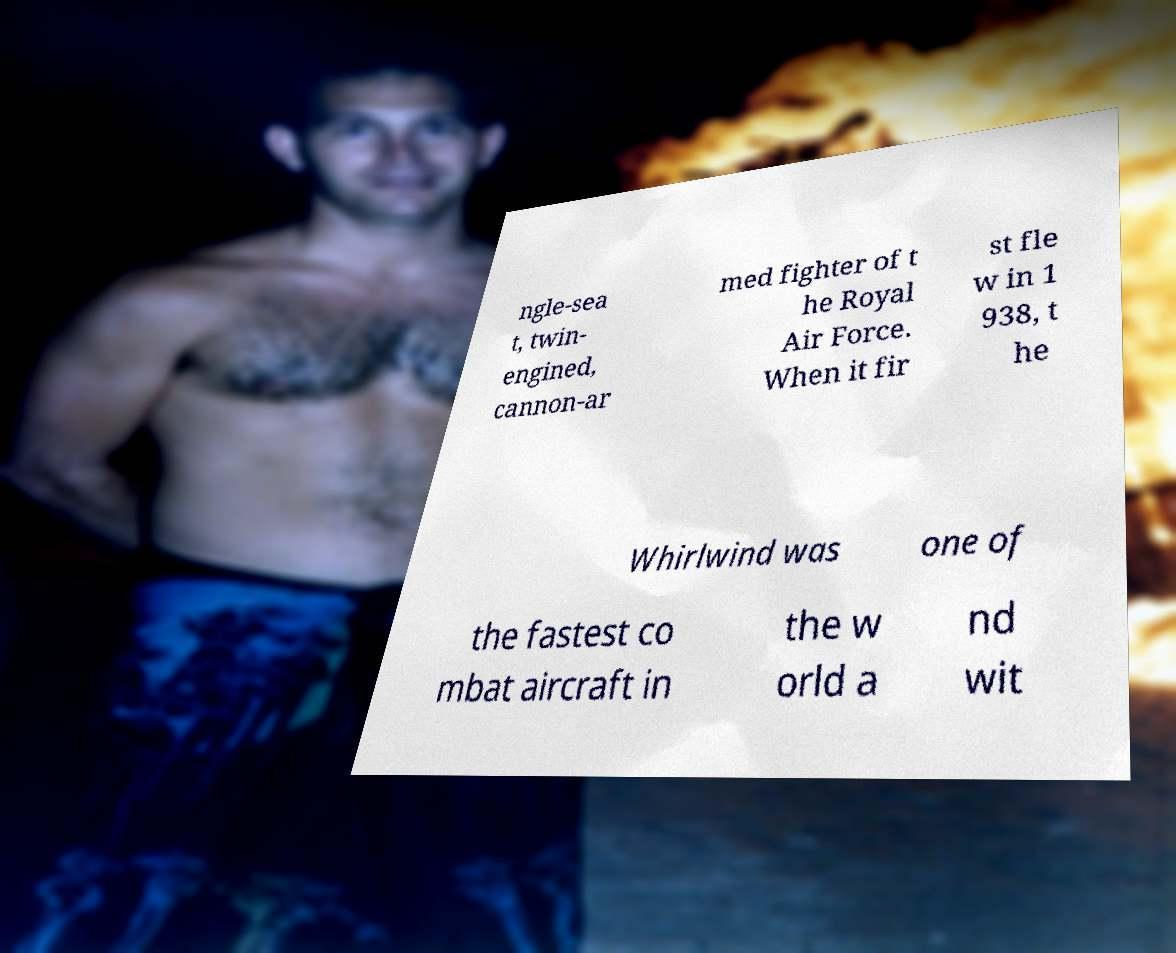For documentation purposes, I need the text within this image transcribed. Could you provide that? ngle-sea t, twin- engined, cannon-ar med fighter of t he Royal Air Force. When it fir st fle w in 1 938, t he Whirlwind was one of the fastest co mbat aircraft in the w orld a nd wit 